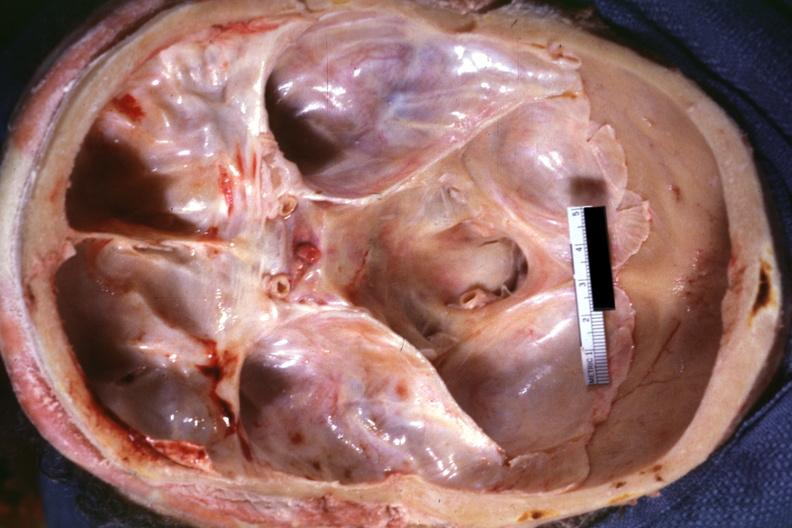s odontoid process subluxation with narrowing of foramen magnum present?
Answer the question using a single word or phrase. Yes 